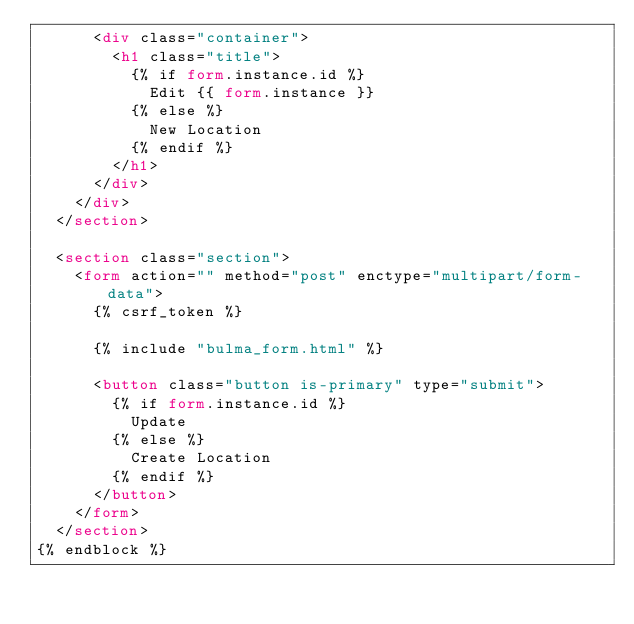Convert code to text. <code><loc_0><loc_0><loc_500><loc_500><_HTML_>      <div class="container">
        <h1 class="title">
          {% if form.instance.id %}
            Edit {{ form.instance }}
          {% else %}
            New Location
          {% endif %}
        </h1>
      </div>
    </div>
  </section>

  <section class="section">
    <form action="" method="post" enctype="multipart/form-data">
      {% csrf_token %}

      {% include "bulma_form.html" %}

      <button class="button is-primary" type="submit">
        {% if form.instance.id %}
          Update
        {% else %}
          Create Location
        {% endif %}
      </button>
    </form>
  </section>
{% endblock %}
</code> 